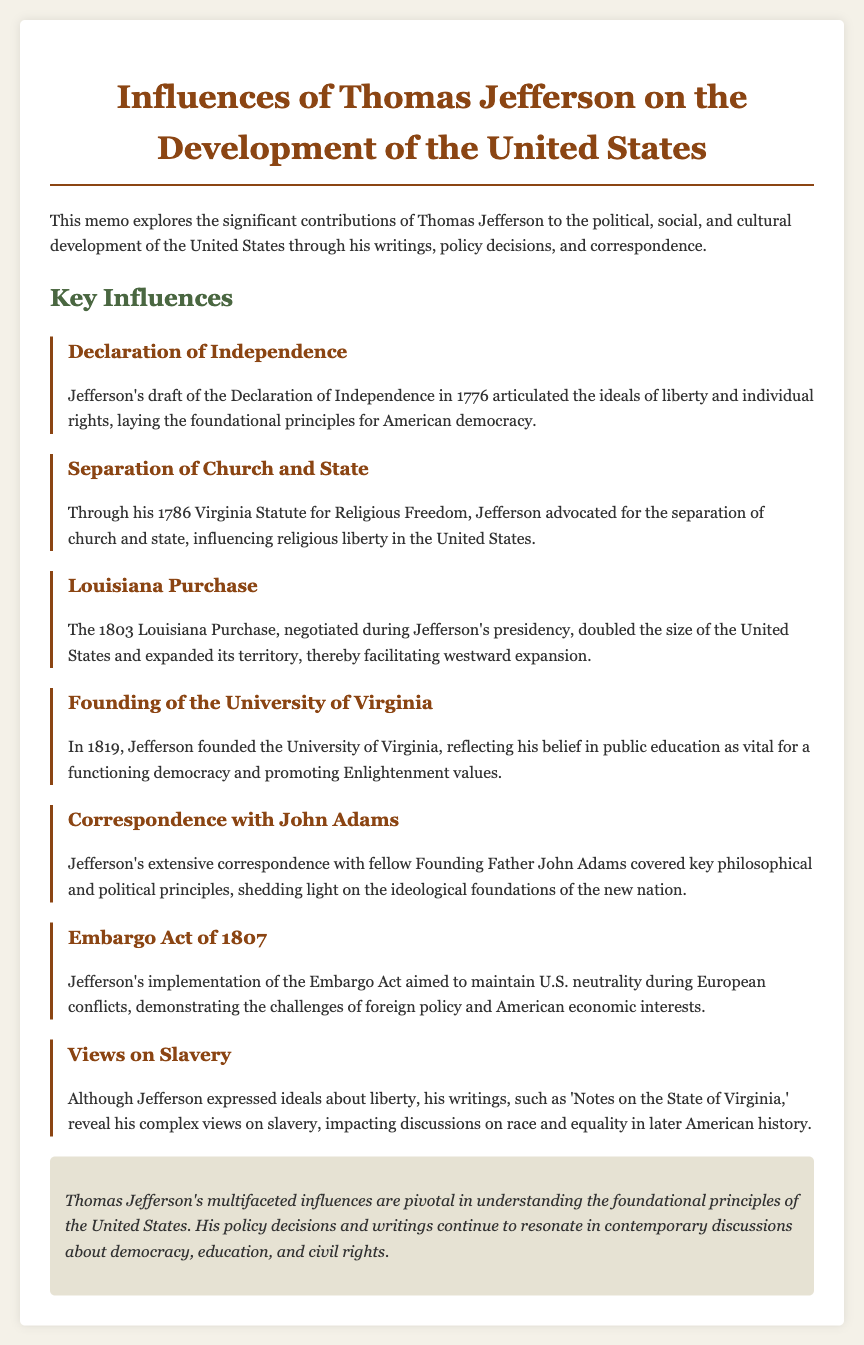What document did Jefferson draft in 1776? The document is the Declaration of Independence, which articulated the ideals of liberty and individual rights.
Answer: Declaration of Independence What year was the Virginia Statute for Religious Freedom enacted? The Virginia Statute for Religious Freedom was enacted in 1786.
Answer: 1786 What major land acquisition did Jefferson negotiate in 1803? The significant land acquisition that Jefferson negotiated was the Louisiana Purchase, which doubled the size of the United States.
Answer: Louisiana Purchase What educational institution did Jefferson found in 1819? Jefferson founded the University of Virginia in 1819, reflecting his belief in the importance of public education.
Answer: University of Virginia Who did Jefferson correspond extensively with regarding philosophical and political principles? Jefferson corresponded extensively with fellow Founding Father John Adams.
Answer: John Adams What act did Jefferson implement in 1807 to maintain U.S. neutrality? Jefferson implemented the Embargo Act in 1807, aiming to maintain U.S. neutrality during European conflicts.
Answer: Embargo Act of 1807 What complex issue did Jefferson address in 'Notes on the State of Virginia'? Jefferson addressed his complex views on slavery in 'Notes on the State of Virginia,' impacting later discussions on race and equality.
Answer: Slavery What is the main theme of Jefferson's influences on the United States as concluded in the memo? The main theme is understanding the foundational principles of the United States, as his influences are pivotal in democracy, education, and civil rights discussions.
Answer: Foundational principles of the United States 